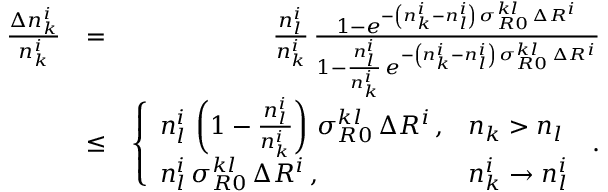<formula> <loc_0><loc_0><loc_500><loc_500>\begin{array} { r l r } { \frac { \Delta n _ { k } ^ { i } } { n _ { k } ^ { i } } } & { = } & { \frac { n _ { l } ^ { i } } { n _ { k } ^ { i } } \, \frac { 1 - e ^ { - \left ( n _ { k } ^ { i } - n _ { l } ^ { i } \right ) \, \sigma _ { R 0 } ^ { k l } \, \Delta R ^ { i } } } { 1 - \frac { n _ { l } ^ { i } } { n _ { k } ^ { i } } \, e ^ { - \left ( n _ { k } ^ { i } - n _ { l } ^ { i } \right ) \, \sigma _ { R 0 } ^ { k l } \, \Delta R ^ { i } } } } \\ & { \leq } & { \left \{ \begin{array} { l l } { n _ { l } ^ { i } \, \left ( 1 - \frac { n _ { l } ^ { i } } { n _ { k } ^ { i } } \right ) \, \sigma _ { R 0 } ^ { k l } \, \Delta R ^ { i } \, , } & { n _ { k } > n _ { l } } \\ { n _ { l } ^ { i } \, \sigma _ { R 0 } ^ { k l } \, \Delta R ^ { i } \, , } & { n _ { k } ^ { i } \rightarrow n _ { l } ^ { i } } \end{array} \, . } \end{array}</formula> 